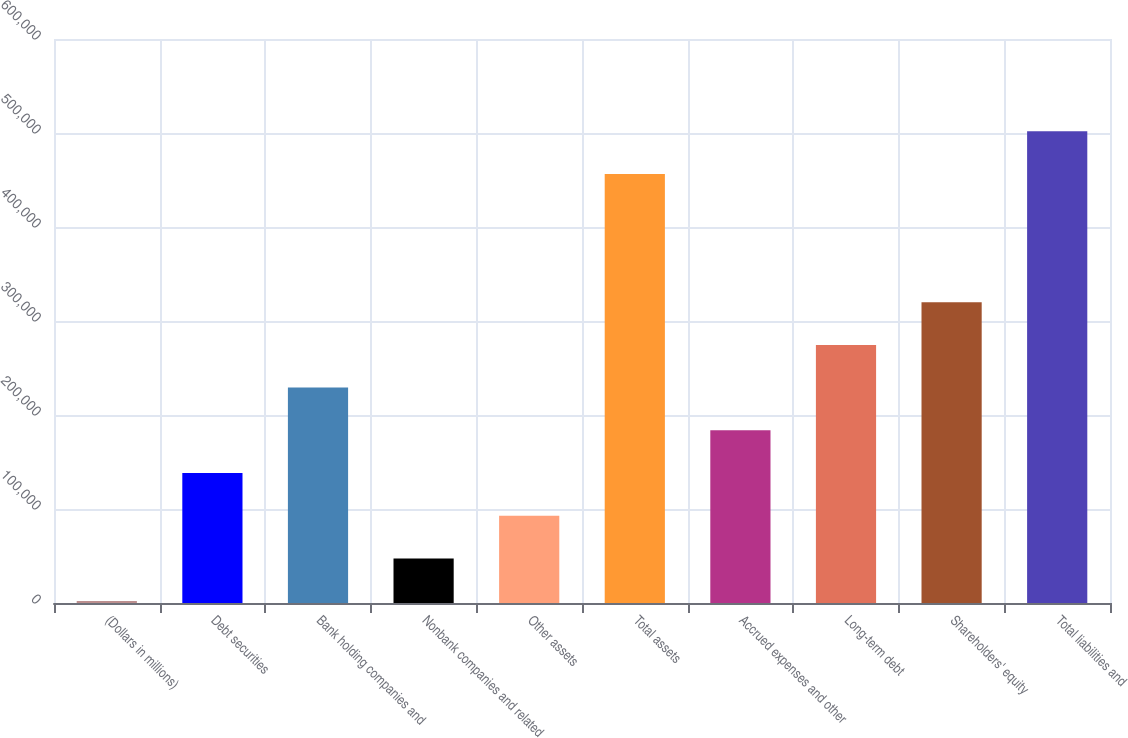Convert chart. <chart><loc_0><loc_0><loc_500><loc_500><bar_chart><fcel>(Dollars in millions)<fcel>Debt securities<fcel>Bank holding companies and<fcel>Nonbank companies and related<fcel>Other assets<fcel>Total assets<fcel>Accrued expenses and other<fcel>Long-term debt<fcel>Shareholders' equity<fcel>Total liabilities and<nl><fcel>2010<fcel>138297<fcel>229155<fcel>47439<fcel>92868<fcel>456300<fcel>183726<fcel>274584<fcel>320013<fcel>501729<nl></chart> 